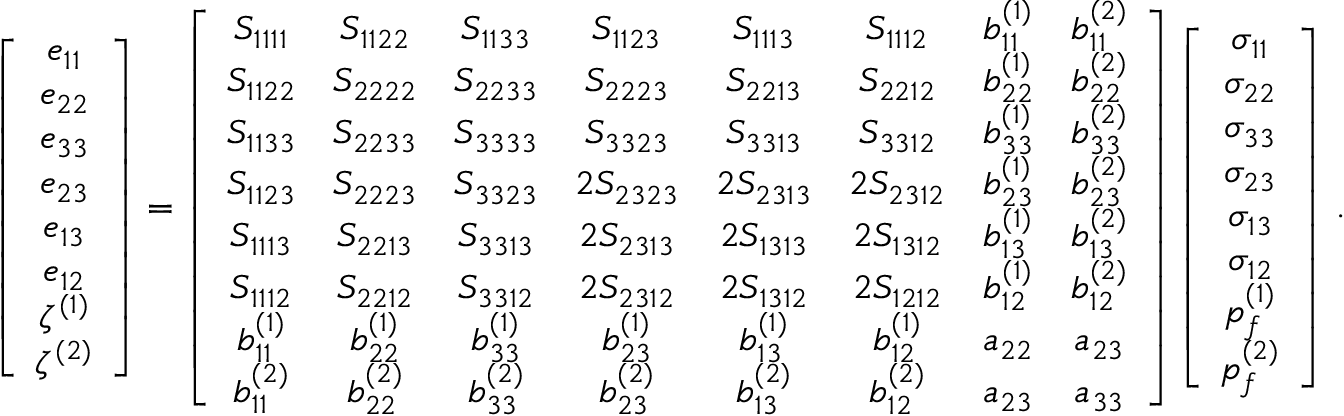<formula> <loc_0><loc_0><loc_500><loc_500>\left [ \begin{array} { c } { e _ { 1 1 } } \\ { e _ { 2 2 } } \\ { e _ { 3 3 } } \\ { e _ { 2 3 } } \\ { e _ { 1 3 } } \\ { e _ { 1 2 } } \\ { \zeta ^ { ( 1 ) } } \\ { \zeta ^ { ( 2 ) } } \end{array} \right ] = \left [ \begin{array} { c c c c c c c c } { S _ { 1 1 1 1 } } & { S _ { 1 1 2 2 } } & { S _ { 1 1 3 3 } } & { S _ { 1 1 2 3 } } & { S _ { 1 1 1 3 } } & { S _ { 1 1 1 2 } } & { b _ { 1 1 } ^ { ( 1 ) } } & { b _ { 1 1 } ^ { ( 2 ) } } \\ { S _ { 1 1 2 2 } } & { S _ { 2 2 2 2 } } & { S _ { 2 2 3 3 } } & { S _ { 2 2 2 3 } } & { S _ { 2 2 1 3 } } & { S _ { 2 2 1 2 } } & { b _ { 2 2 } ^ { ( 1 ) } } & { b _ { 2 2 } ^ { ( 2 ) } } \\ { S _ { 1 1 3 3 } } & { S _ { 2 2 3 3 } } & { S _ { 3 3 3 3 } } & { S _ { 3 3 2 3 } } & { S _ { 3 3 1 3 } } & { S _ { 3 3 1 2 } } & { b _ { 3 3 } ^ { ( 1 ) } } & { b _ { 3 3 } ^ { ( 2 ) } } \\ { S _ { 1 1 2 3 } } & { S _ { 2 2 2 3 } } & { S _ { 3 3 2 3 } } & { 2 S _ { 2 3 2 3 } } & { 2 S _ { 2 3 1 3 } } & { 2 S _ { 2 3 1 2 } } & { b _ { 2 3 } ^ { ( 1 ) } } & { b _ { 2 3 } ^ { ( 2 ) } } \\ { S _ { 1 1 1 3 } } & { S _ { 2 2 1 3 } } & { S _ { 3 3 1 3 } } & { 2 S _ { 2 3 1 3 } } & { 2 S _ { 1 3 1 3 } } & { 2 S _ { 1 3 1 2 } } & { b _ { 1 3 } ^ { ( 1 ) } } & { b _ { 1 3 } ^ { ( 2 ) } } \\ { S _ { 1 1 1 2 } } & { S _ { 2 2 1 2 } } & { S _ { 3 3 1 2 } } & { 2 S _ { 2 3 1 2 } } & { 2 S _ { 1 3 1 2 } } & { 2 S _ { 1 2 1 2 } } & { b _ { 1 2 } ^ { ( 1 ) } } & { b _ { 1 2 } ^ { ( 2 ) } } \\ { b _ { 1 1 } ^ { ( 1 ) } } & { b _ { 2 2 } ^ { ( 1 ) } } & { b _ { 3 3 } ^ { ( 1 ) } } & { b _ { 2 3 } ^ { ( 1 ) } } & { b _ { 1 3 } ^ { ( 1 ) } } & { b _ { 1 2 } ^ { ( 1 ) } } & { a _ { 2 2 } } & { a _ { 2 3 } } \\ { b _ { 1 1 } ^ { ( 2 ) } } & { b _ { 2 2 } ^ { ( 2 ) } } & { b _ { 3 3 } ^ { ( 2 ) } } & { b _ { 2 3 } ^ { ( 2 ) } } & { b _ { 1 3 } ^ { ( 2 ) } } & { b _ { 1 2 } ^ { ( 2 ) } } & { a _ { 2 3 } } & { a _ { 3 3 } } \end{array} \right ] \left [ \begin{array} { c } { \sigma _ { 1 1 } } \\ { \sigma _ { 2 2 } } \\ { \sigma _ { 3 3 } } \\ { \sigma _ { 2 3 } } \\ { \sigma _ { 1 3 } } \\ { \sigma _ { 1 2 } } \\ { p _ { f } ^ { ( 1 ) } } \\ { p _ { f } ^ { ( 2 ) } } \end{array} \right ] \, .</formula> 